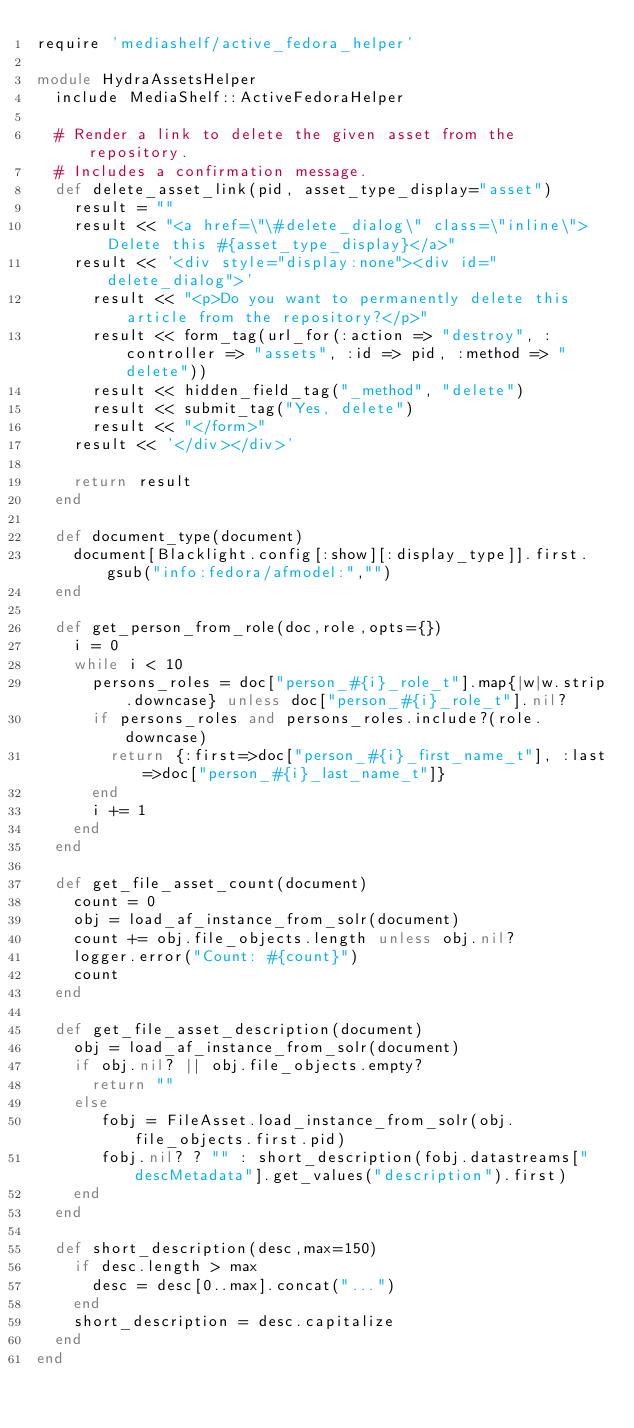Convert code to text. <code><loc_0><loc_0><loc_500><loc_500><_Ruby_>require 'mediashelf/active_fedora_helper'

module HydraAssetsHelper
  include MediaShelf::ActiveFedoraHelper

  # Render a link to delete the given asset from the repository.
  # Includes a confirmation message. 
  def delete_asset_link(pid, asset_type_display="asset")
    result = ""
    result << "<a href=\"\#delete_dialog\" class=\"inline\">Delete this #{asset_type_display}</a>"
    result << '<div style="display:none"><div id="delete_dialog">'
      result << "<p>Do you want to permanently delete this article from the repository?</p>"
      result << form_tag(url_for(:action => "destroy", :controller => "assets", :id => pid, :method => "delete"))
      result << hidden_field_tag("_method", "delete")
      result << submit_tag("Yes, delete")
      result << "</form>"
    result << '</div></div>'
    
    return result    
  end

  def document_type(document)
    document[Blacklight.config[:show][:display_type]].first.gsub("info:fedora/afmodel:","")
  end

  def get_person_from_role(doc,role,opts={})  
    i = 0
    while i < 10
      persons_roles = doc["person_#{i}_role_t"].map{|w|w.strip.downcase} unless doc["person_#{i}_role_t"].nil?
      if persons_roles and persons_roles.include?(role.downcase)
        return {:first=>doc["person_#{i}_first_name_t"], :last=>doc["person_#{i}_last_name_t"]}
      end
      i += 1
    end
  end

  def get_file_asset_count(document)
    count = 0
    obj = load_af_instance_from_solr(document)
    count += obj.file_objects.length unless obj.nil?
    logger.error("Count: #{count}")
    count
  end
  
  def get_file_asset_description(document)
    obj = load_af_instance_from_solr(document)
    if obj.nil? || obj.file_objects.empty?
      return ""
    else
       fobj = FileAsset.load_instance_from_solr(obj.file_objects.first.pid)
       fobj.nil? ? "" : short_description(fobj.datastreams["descMetadata"].get_values("description").first)
    end
  end

  def short_description(desc,max=150)
    if desc.length > max
      desc = desc[0..max].concat("...")
    end
    short_description = desc.capitalize
  end
end
</code> 